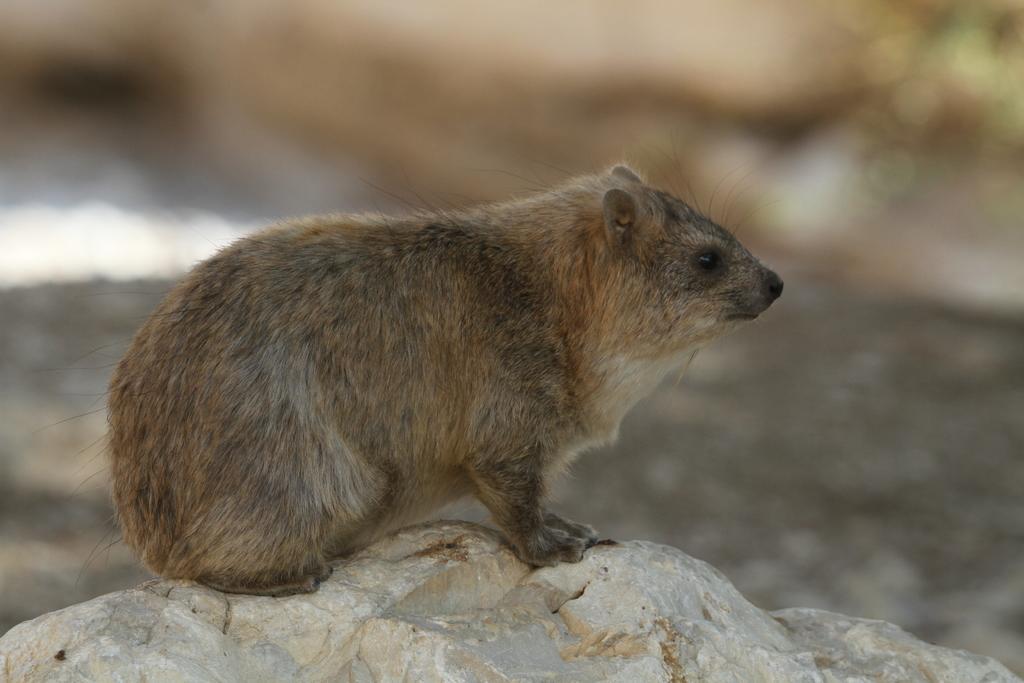Please provide a concise description of this image. In the center of the picture there is a groundhog on a stone. The background is blurred. 